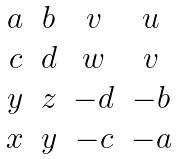<formula> <loc_0><loc_0><loc_500><loc_500>\begin{matrix} a & b & v & u \\ c & d & w & v \\ y & z & - d & - b \\ x & y & - c & - a \end{matrix}</formula> 